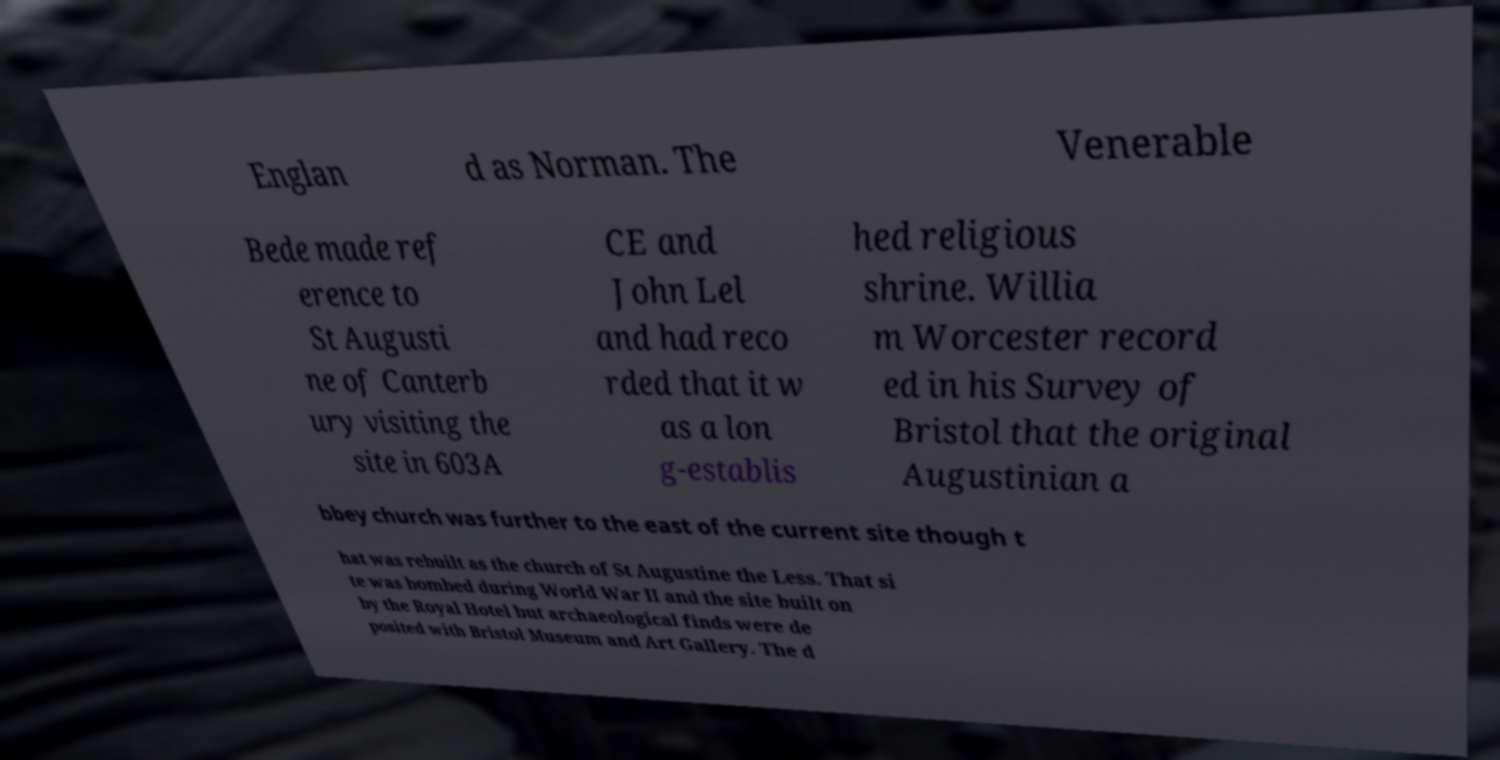I need the written content from this picture converted into text. Can you do that? Englan d as Norman. The Venerable Bede made ref erence to St Augusti ne of Canterb ury visiting the site in 603A CE and John Lel and had reco rded that it w as a lon g-establis hed religious shrine. Willia m Worcester record ed in his Survey of Bristol that the original Augustinian a bbey church was further to the east of the current site though t hat was rebuilt as the church of St Augustine the Less. That si te was bombed during World War II and the site built on by the Royal Hotel but archaeological finds were de posited with Bristol Museum and Art Gallery. The d 